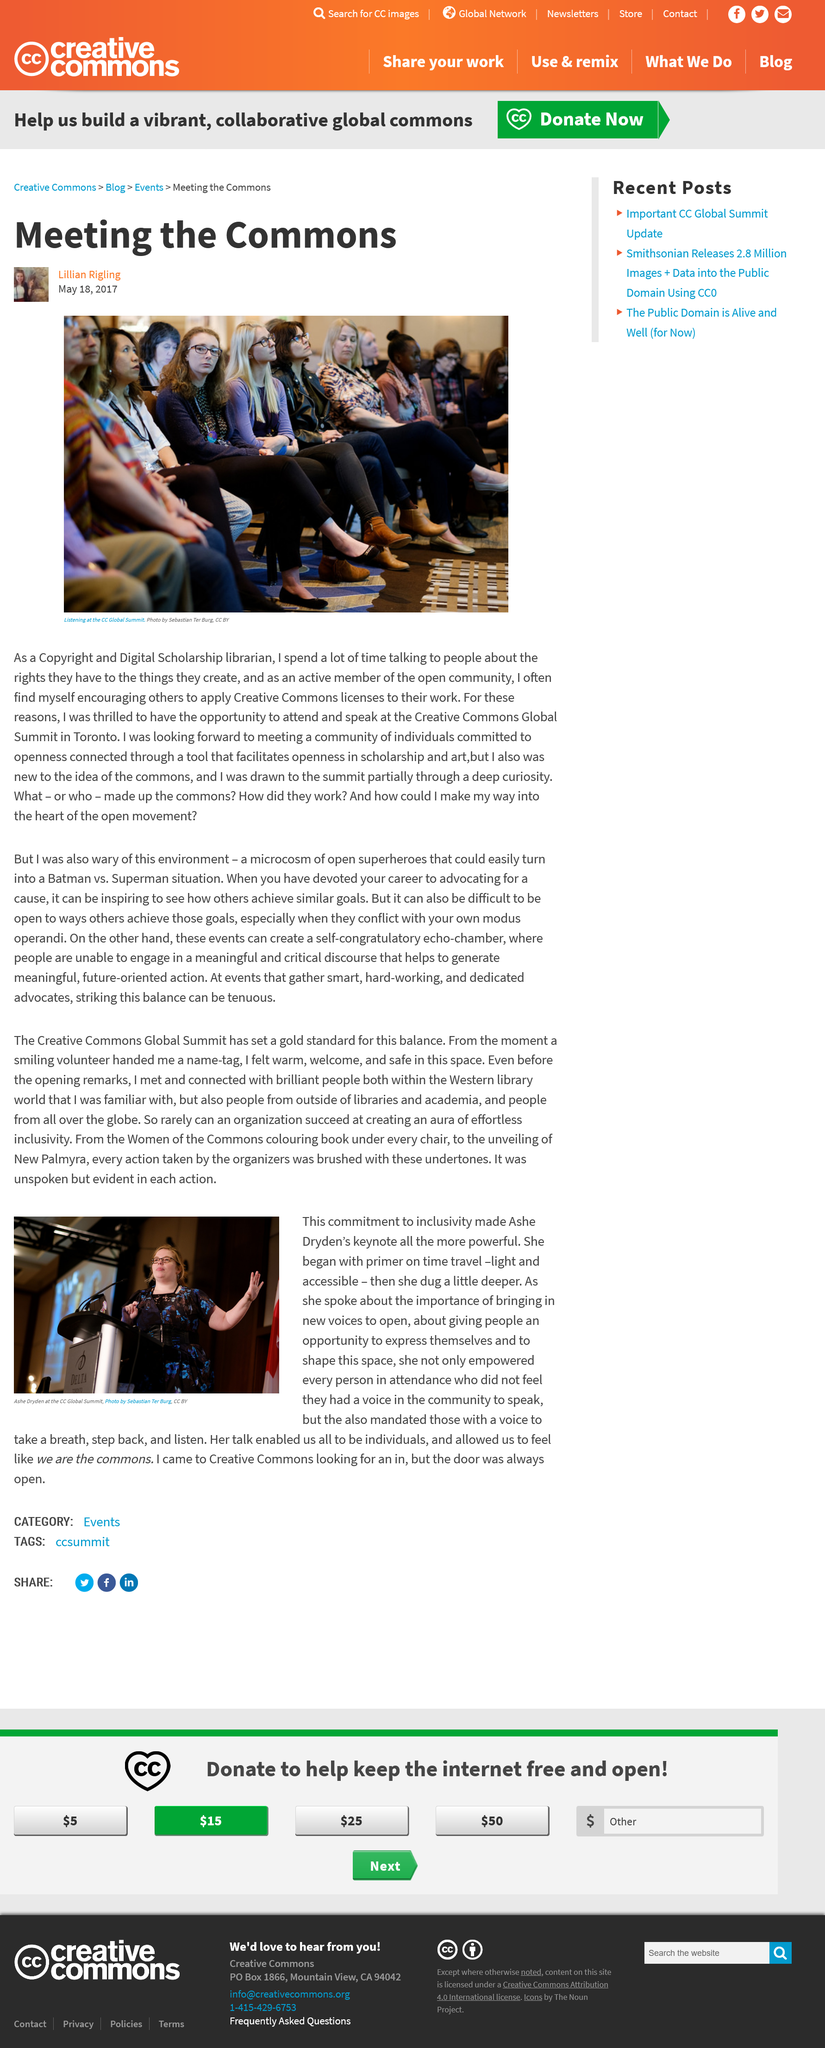Highlight a few significant elements in this photo. Lillian Rigling is a Copyright and Digital Scholarship librarian. The Creative Commons Global Summit was held in Toronto in 2017. Dryden's keynote began with the topic of time travel. Yes, Dryden empowered some individuals to speak and mandated others to listen. In the photo used for this article, zero men are visible. 